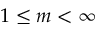Convert formula to latex. <formula><loc_0><loc_0><loc_500><loc_500>1 \leq m < \infty</formula> 